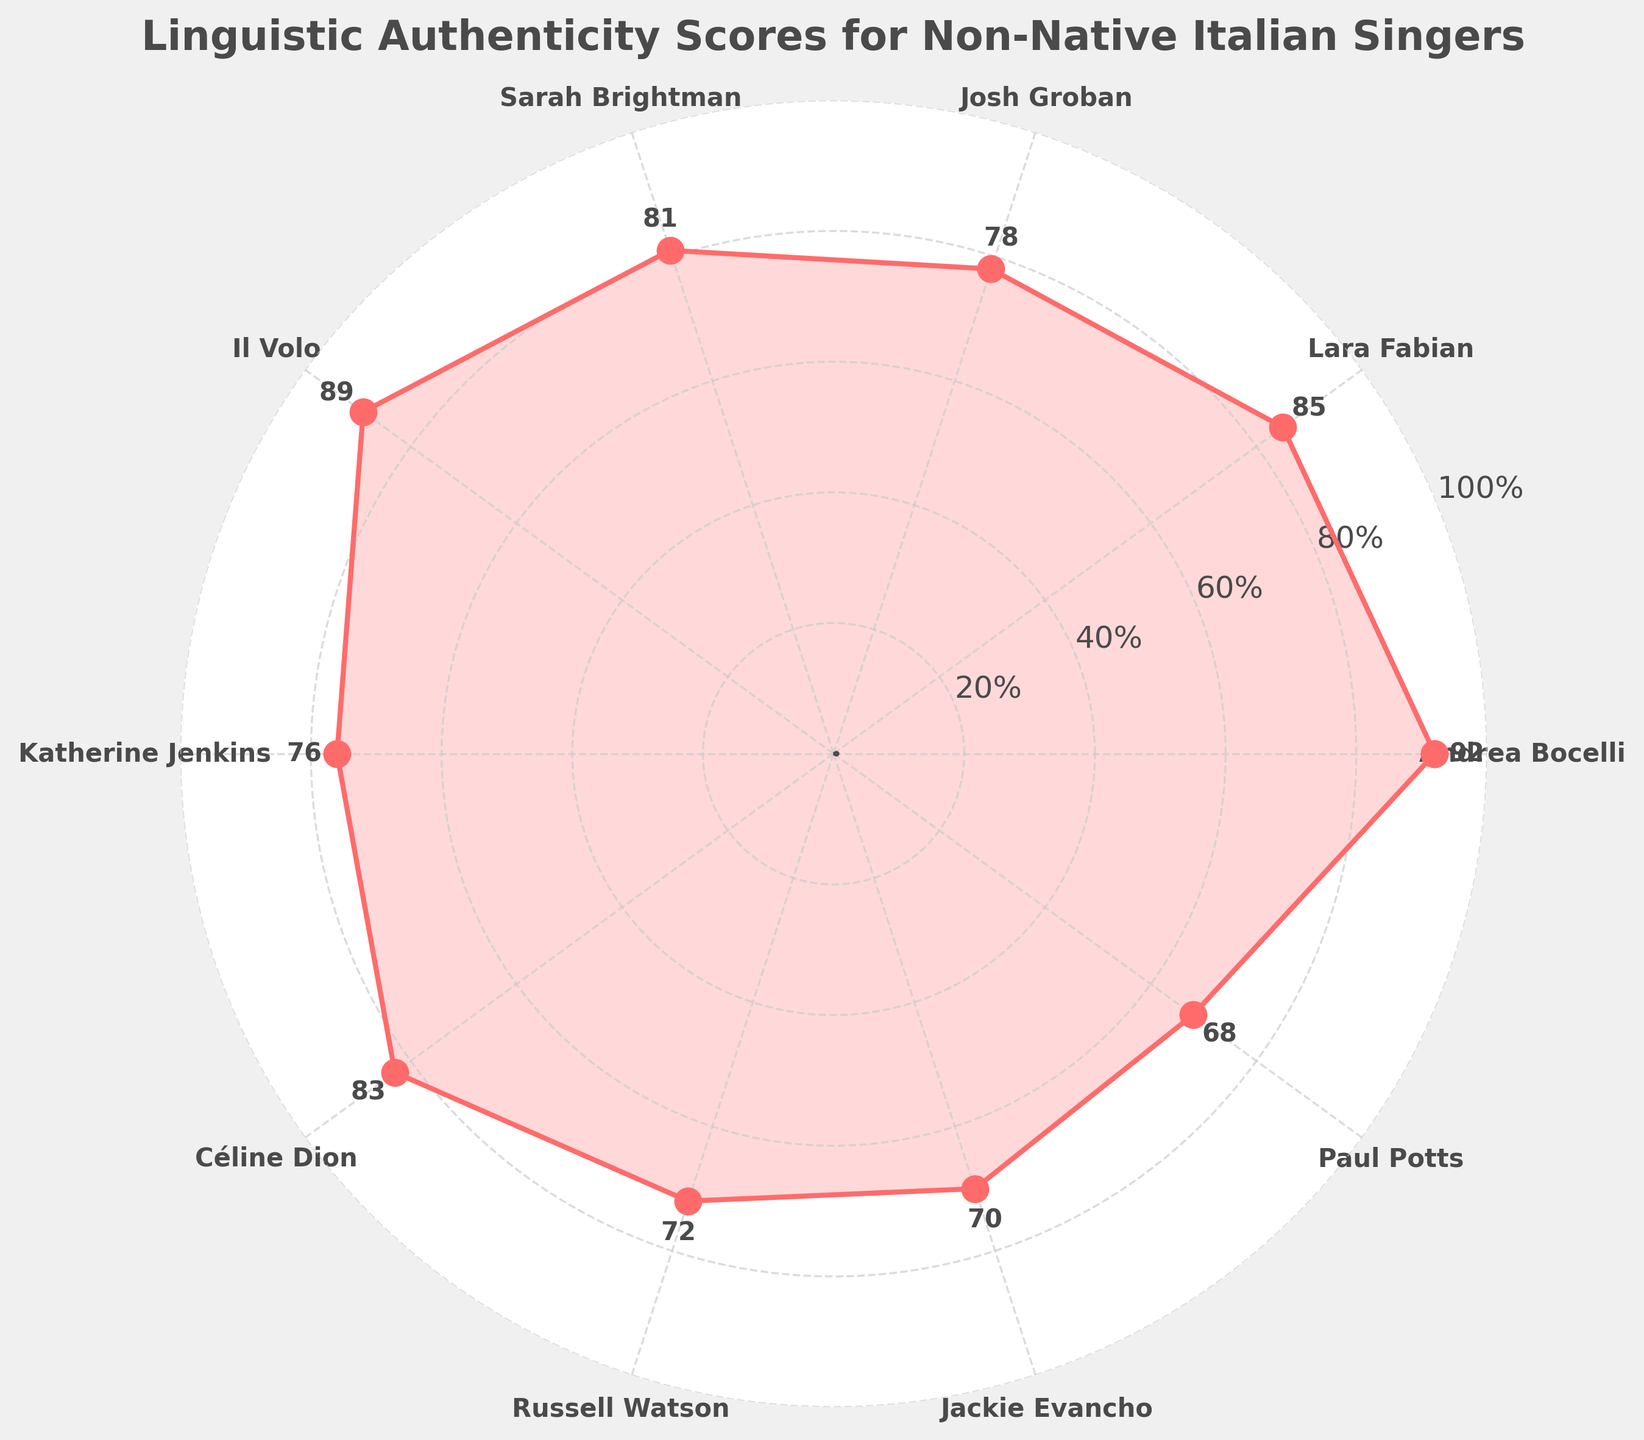Which singer has the highest authenticity score? Refer to the plot and identify the singer with the highest point on the chart. Andrea Bocelli is at the top with a score of 92.
Answer: Andrea Bocelli Which singer has the lowest authenticity score? Refer to the plot and identify the singer with the lowest point on the chart. Paul Potts is at the bottom with a score of 68.
Answer: Paul Potts What is the average authenticity score of all the singers? Sum all the scores and divide by the number of singers. The sum is 794, and there are 10 singers. 794 / 10 = 79.4
Answer: 79.4 How many singers scored above 80? Identify the number of singers with points above the 80 mark. There are five singers: Andrea Bocelli, Lara Fabian, Il Volo, Sarah Brightman, and Céline Dion.
Answer: 5 How does Katherine Jenkins' score compare to Céline Dion's? Compare the positions of Katherine Jenkins and Céline Dion on the chart. Katherine Jenkins scored 76, and Céline Dion scored 83. Katherine Jenkins' score is lower.
Answer: Lower Who scored exactly in the middle of all singers? Arrange scores in ascending order (68, 70, 72, 76, 78, 81, 83, 85, 89, 92) and find the middle value. The average of the 5th and 6th values (78 and 81) is 79.5, closest to Josh Groban and Sarah Brightman. Sarah Brightman is the sixth singer.
Answer: Sarah Brightman What's the total difference in scores between the highest-scoring singer and the lowest-scoring singer? Subtract the lowest score (68) from the highest score (92). 92 - 68 = 24
Answer: 24 Which singers scored between 70 and 80? Identify the singers whose points fall in the 70-80 range. Katherine Jenkins (76), Josh Groban (78), Russell Watson (72), and Jackie Evancho (70) meet this criterion.
Answer: Katherine Jenkins, Josh Groban, Russell Watson, Jackie Evancho 